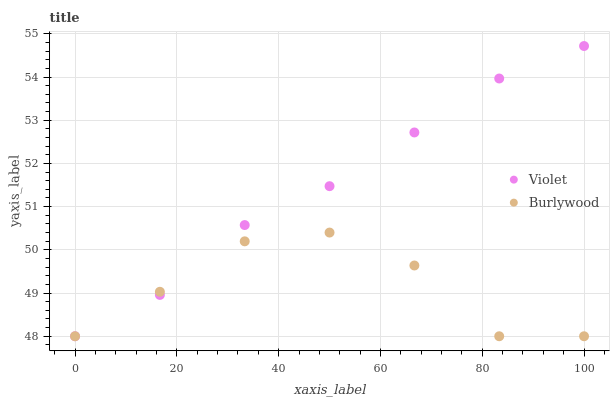Does Burlywood have the minimum area under the curve?
Answer yes or no. Yes. Does Violet have the maximum area under the curve?
Answer yes or no. Yes. Does Violet have the minimum area under the curve?
Answer yes or no. No. Is Violet the smoothest?
Answer yes or no. Yes. Is Burlywood the roughest?
Answer yes or no. Yes. Is Violet the roughest?
Answer yes or no. No. Does Burlywood have the lowest value?
Answer yes or no. Yes. Does Violet have the highest value?
Answer yes or no. Yes. Does Violet intersect Burlywood?
Answer yes or no. Yes. Is Violet less than Burlywood?
Answer yes or no. No. Is Violet greater than Burlywood?
Answer yes or no. No. 